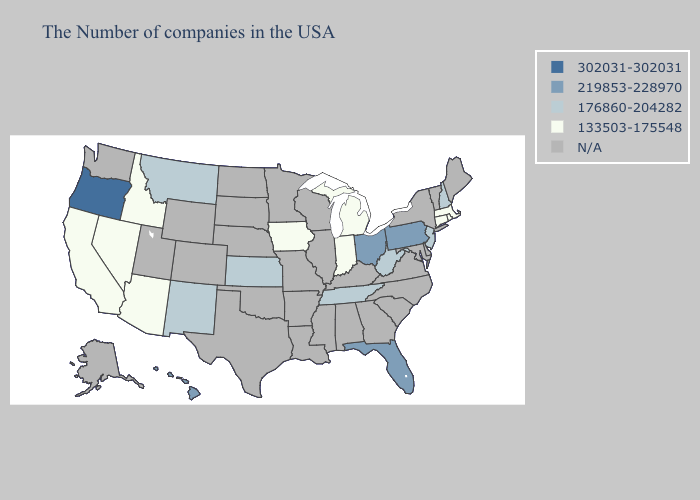Does the map have missing data?
Keep it brief. Yes. Does the first symbol in the legend represent the smallest category?
Short answer required. No. Does Ohio have the highest value in the USA?
Keep it brief. No. What is the highest value in the MidWest ?
Be succinct. 219853-228970. What is the value of Oregon?
Keep it brief. 302031-302031. What is the highest value in the USA?
Short answer required. 302031-302031. What is the highest value in the South ?
Short answer required. 219853-228970. What is the value of New Hampshire?
Concise answer only. 176860-204282. What is the value of Wyoming?
Write a very short answer. N/A. Among the states that border Idaho , does Oregon have the highest value?
Give a very brief answer. Yes. What is the highest value in the USA?
Give a very brief answer. 302031-302031. Does Montana have the lowest value in the West?
Short answer required. No. How many symbols are there in the legend?
Be succinct. 5. Which states have the highest value in the USA?
Short answer required. Oregon. 